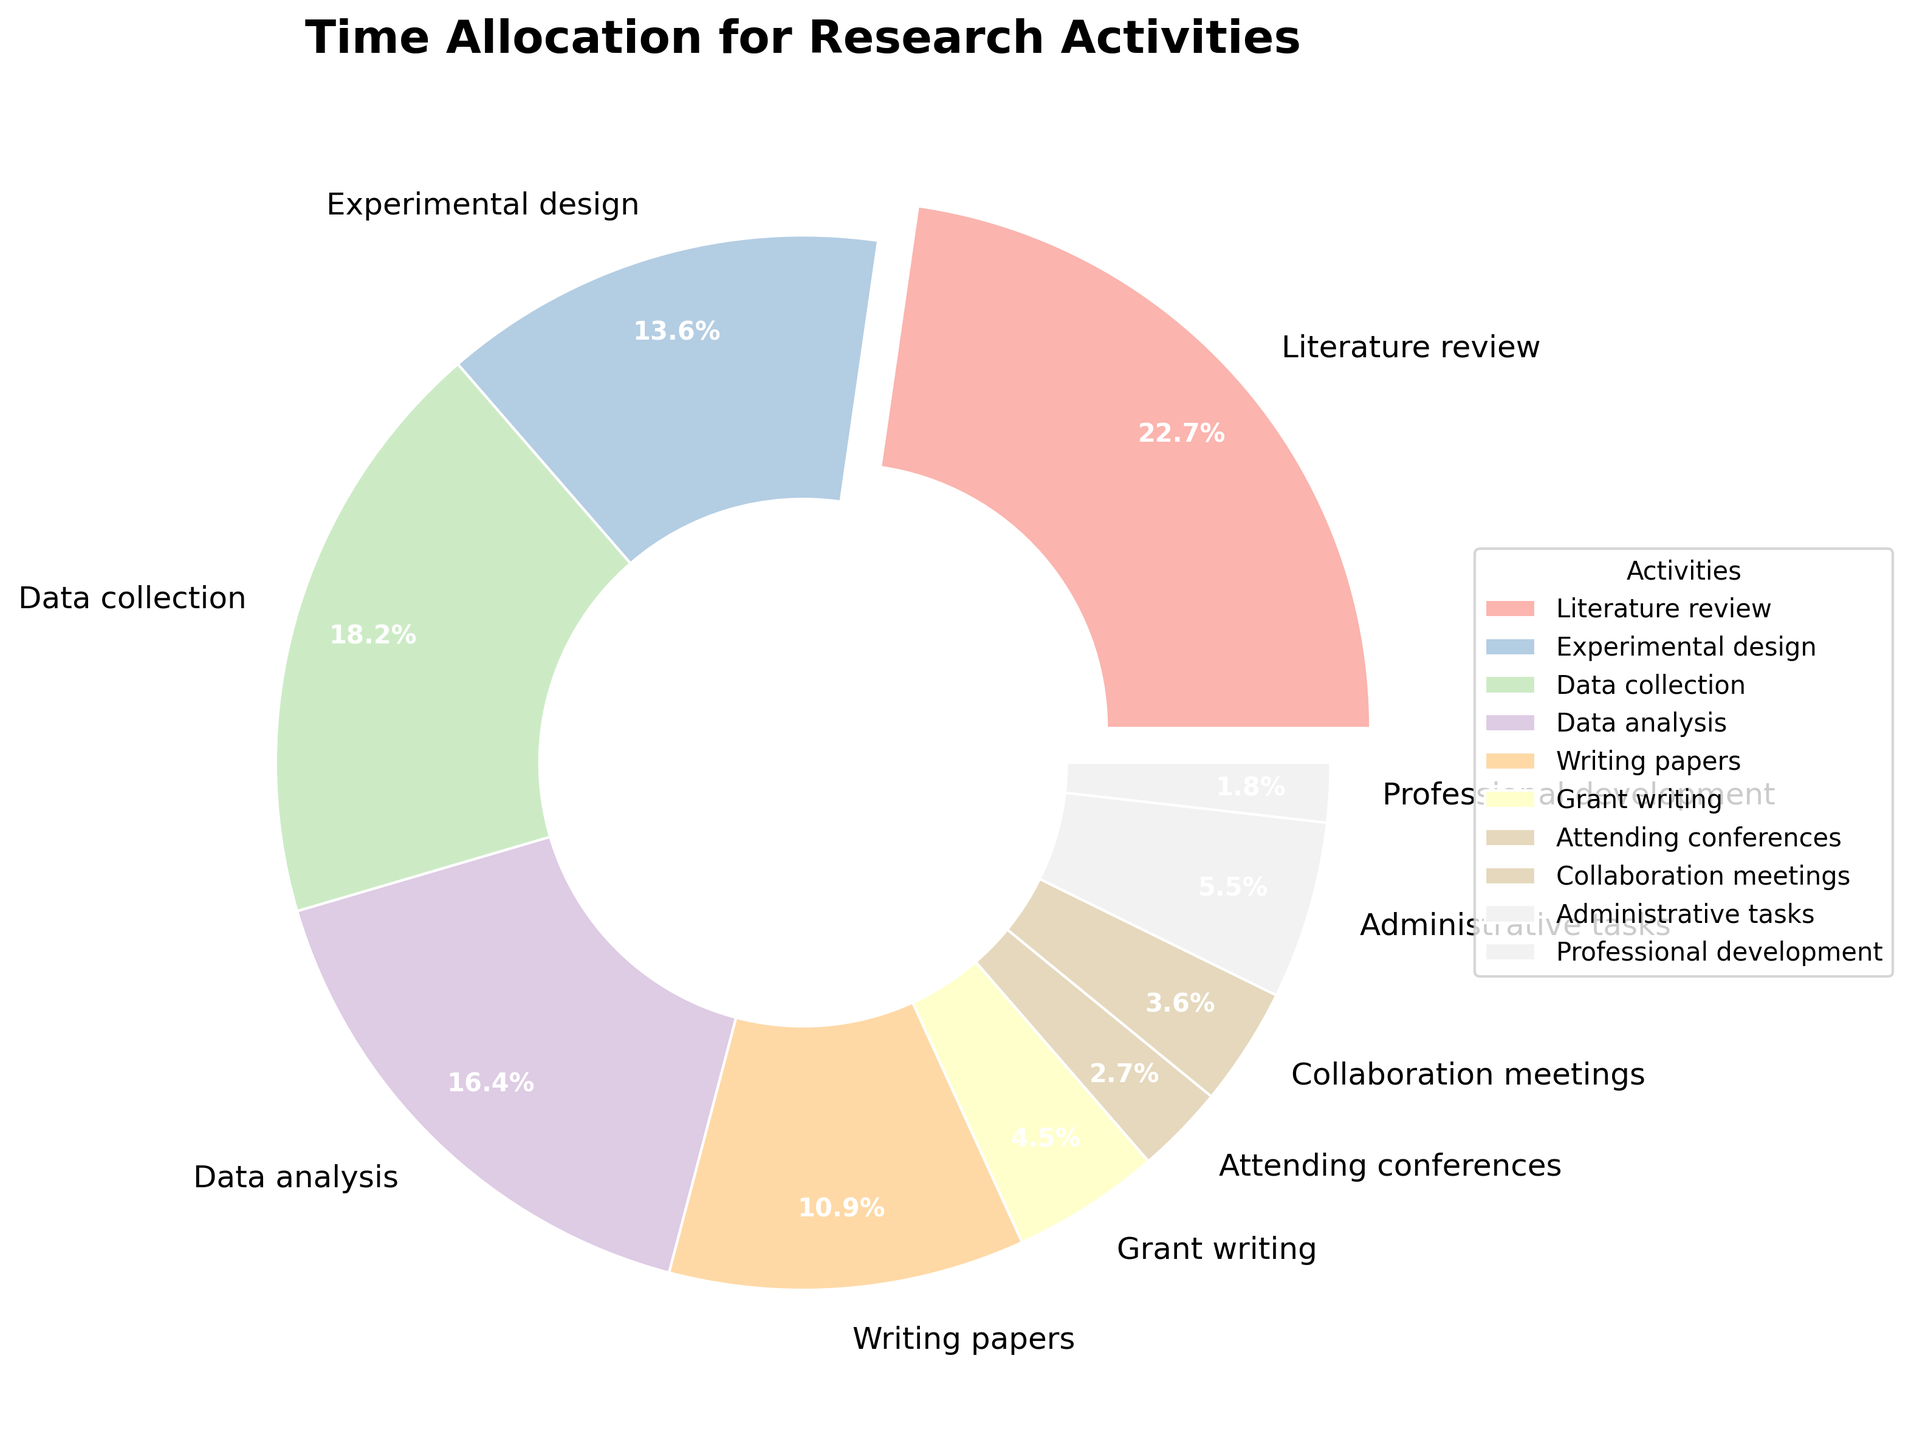What activity takes up the largest portion of time allocation? The largest portion of time allocation is represented by the activity with the largest percentage. According to the figure, "Literature review" occupies the largest percentage at 25%.
Answer: Literature review What is the combined percentage of time spent on writing papers and grant writing? Add the percentage of time spent on "Writing papers" (12%) and "Grant writing" (5%). 12% + 5% = 17%.
Answer: 17% Is the percentage of time spent on experimental design greater than attending conferences? Compare the percentages: Experimental design is 15%, and attending conferences is 3%. Since 15% is greater than 3%, the time spent on experimental design is greater.
Answer: Yes Which activity takes up more time, collaboration meetings or administrative tasks? Look at the percentages: Collaboration meetings take up 4%, and administrative tasks take up 6%. Since 6% is greater than 4%, administrative tasks take up more time.
Answer: Administrative tasks What is the percentage difference between data collection and data analysis? Subtract the percentage of data analysis (18%) from data collection (20%). 20% - 18% = 2%.
Answer: 2% How much more time is allocated to professional development compared to attending conferences? Compare the percentages: Professional development is 2%, and attending conferences is 3%. Subtract 2% from 3%, which gives -1%. So, attending conferences takes more time.
Answer: -1% If you combine the time spent on professional development and collaboration meetings, what would be the combined percentage? Add the percentages for collaboration meetings (4%) and professional development (2%). 4% + 2% = 6%.
Answer: 6% Are there more time allocation categories with a higher percentage than data analysis or fewer? Data analysis is 18%. Categories with higher percentages are: Literature review (25%), and Data collection (20%). So, there are 2 categories with higher percentages.
Answer: More 